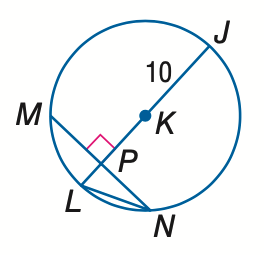Answer the mathemtical geometry problem and directly provide the correct option letter.
Question: In \odot K, M N = 16 and m \widehat M N = 98. Find the measure of m \widehat N J. Round to the nearest hundredth.
Choices: A: 49.00 B: 82.00 C: 98.00 D: 131.00 D 